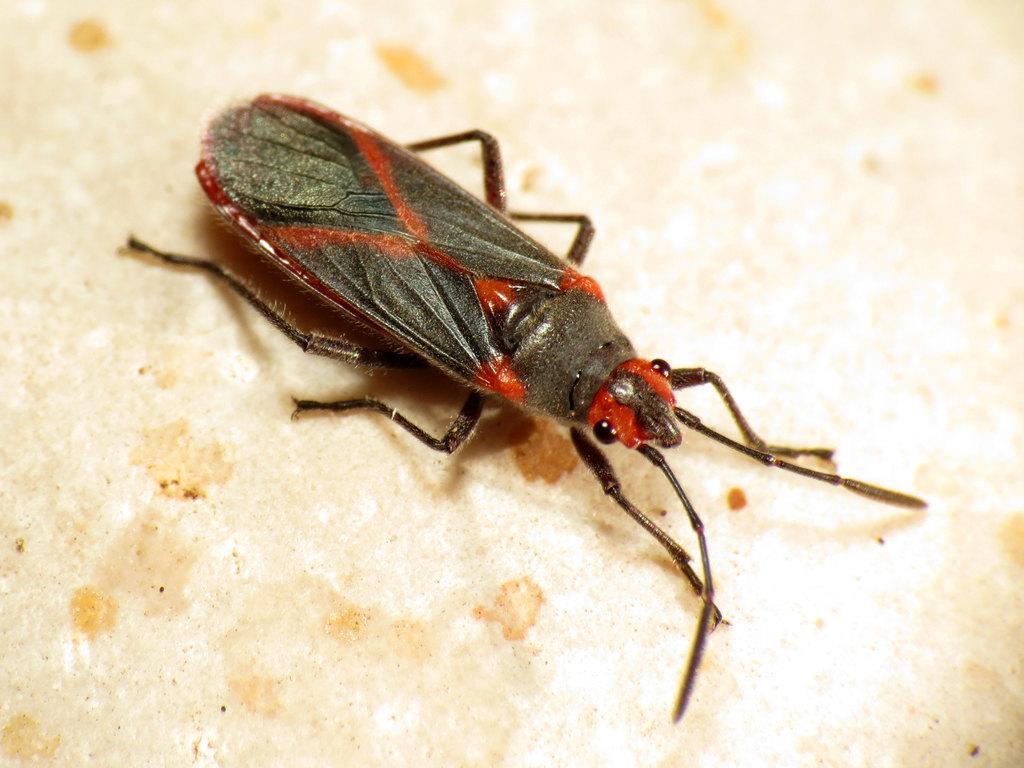Could you give a brief overview of what you see in this image? In this image we can see an insect on the surface. 